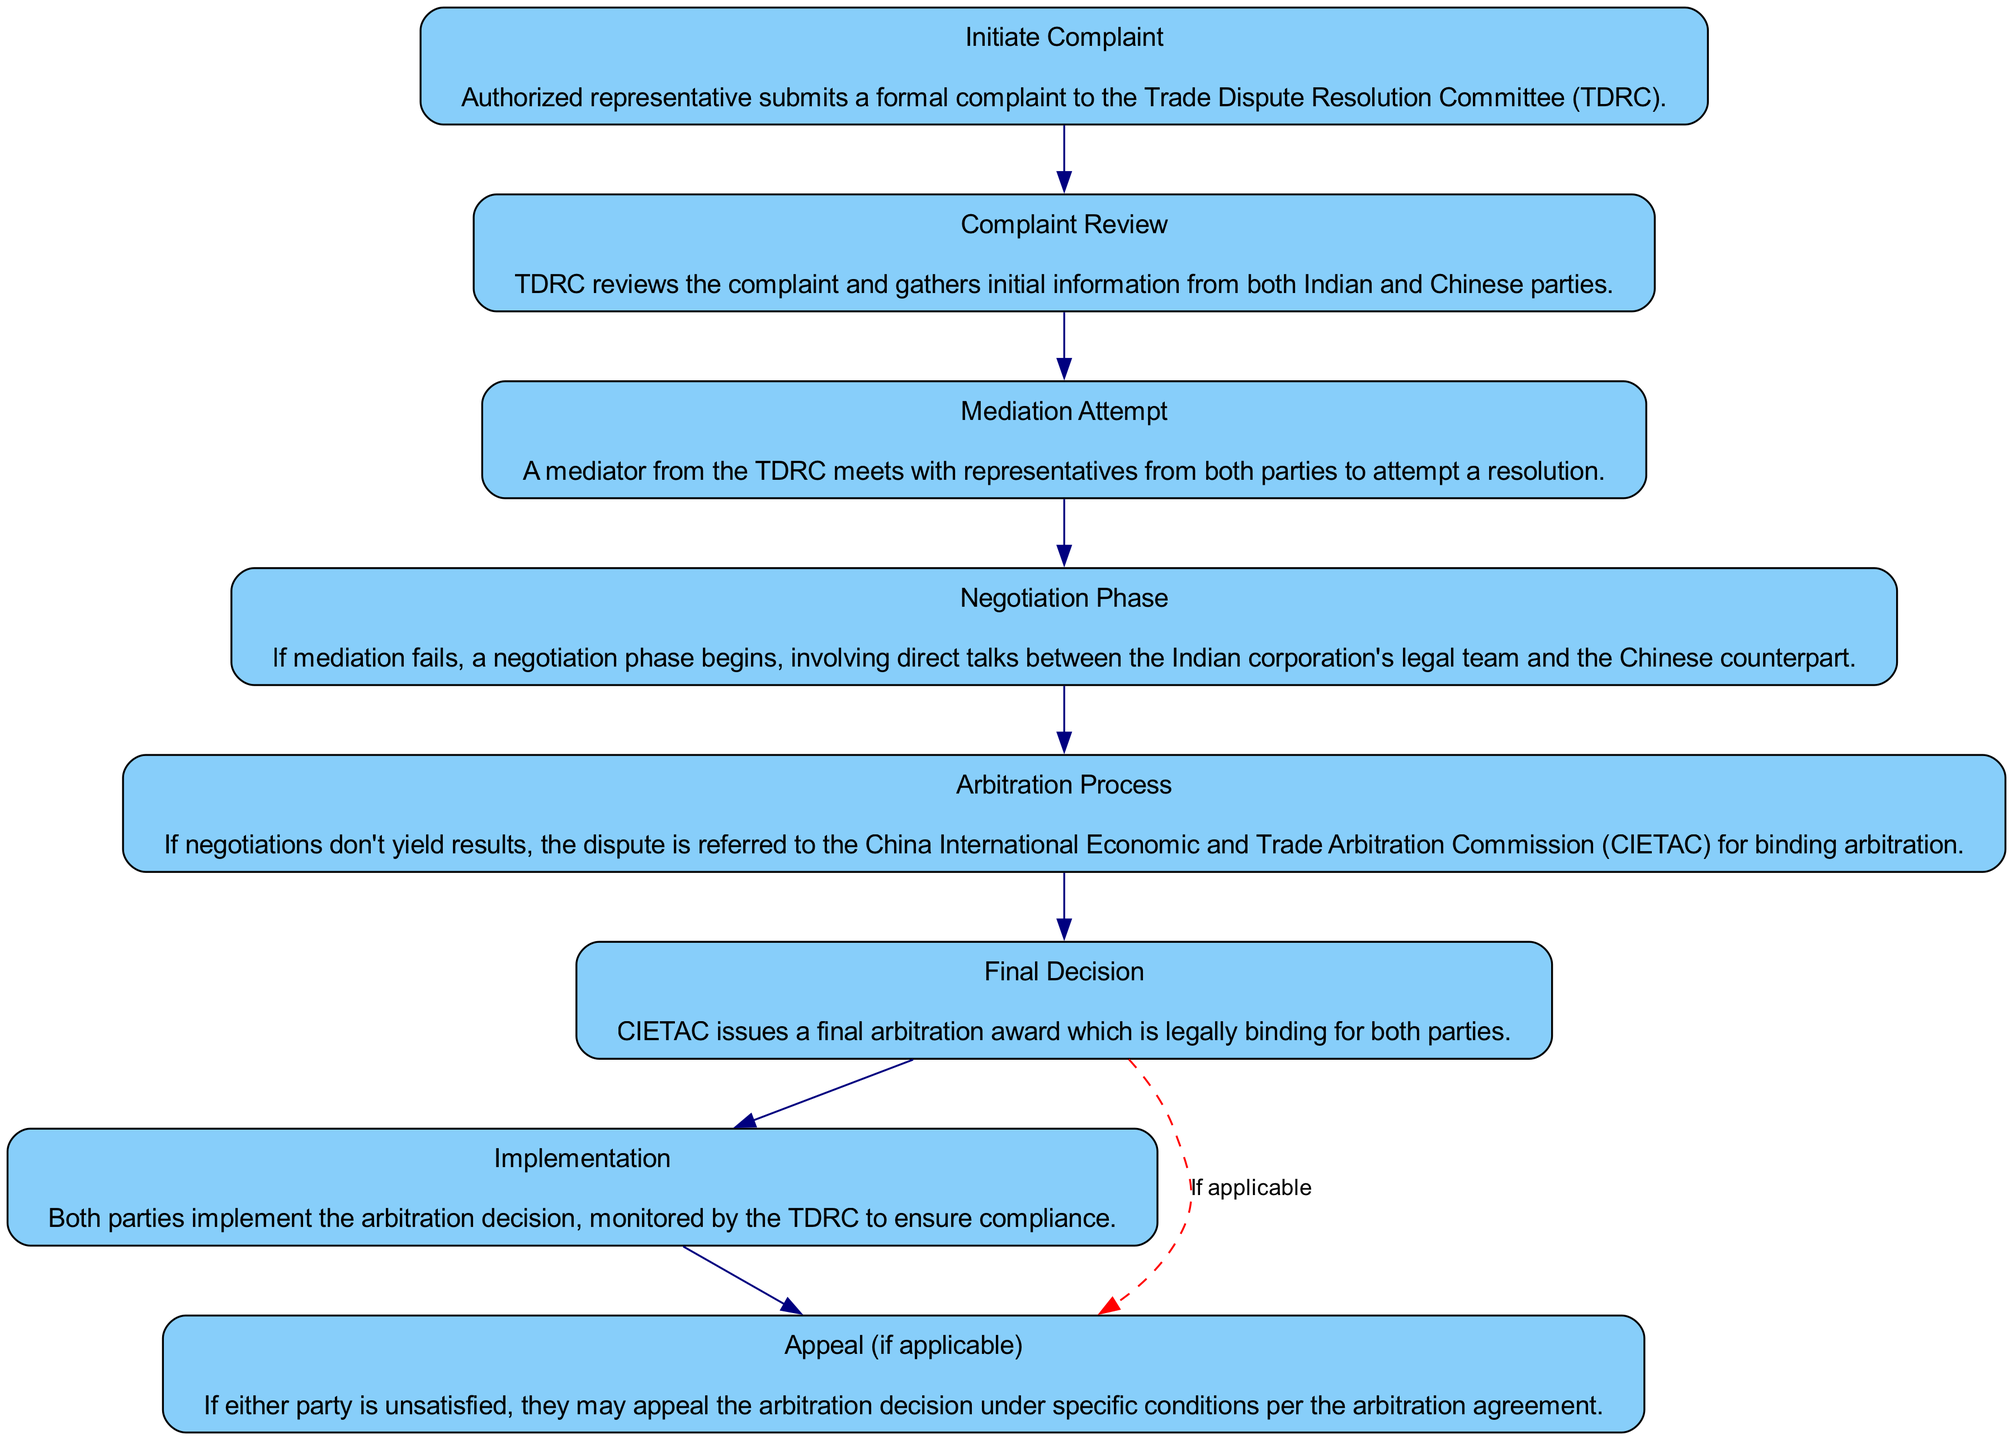What is the first step in the protocol? The first step listed in the flowchart is "Initiate Complaint." This is where the authorized representative submits a formal complaint to the Trade Dispute Resolution Committee (TDRC).
Answer: Initiate Complaint How many steps are in the flowchart? By counting all distinct steps in the flowchart elements, there are a total of 8 steps included in the protocol for handling trade disputes.
Answer: 8 What follows the "Mediation Attempt" step? After the "Mediation Attempt" step, if mediation fails, the flowchart indicates that it moves to the "Negotiation Phase," which involves direct talks between legal teams.
Answer: Negotiation Phase Which step involves binding arbitration? The step that involves binding arbitration is "Arbitration Process," where disputes are referred to the China International Economic and Trade Arbitration Commission (CIETAC) for resolution.
Answer: Arbitration Process What is the last step of the protocol? The last step illustrated in the flowchart is "Implementation," where both parties are to implement the arbitration decision as monitored by the TDRC.
Answer: Implementation What happens if negotiations fail? If negotiations fail, according to the flowchart, the next step is the "Arbitration Process" where the dispute is referred for binding arbitration.
Answer: Arbitration Process What condition allows for an appeal? An appeal can be made "if applicable," which is indicated by a dashed red line branching off from the final decision step and goes to the appeal step under specific conditions per the arbitration agreement.
Answer: if applicable How is the "Final Decision" described in the flowchart? The "Final Decision" is described as the step where CIETAC issues a final arbitration award that is legally binding for both parties involved in the dispute.
Answer: legally binding 